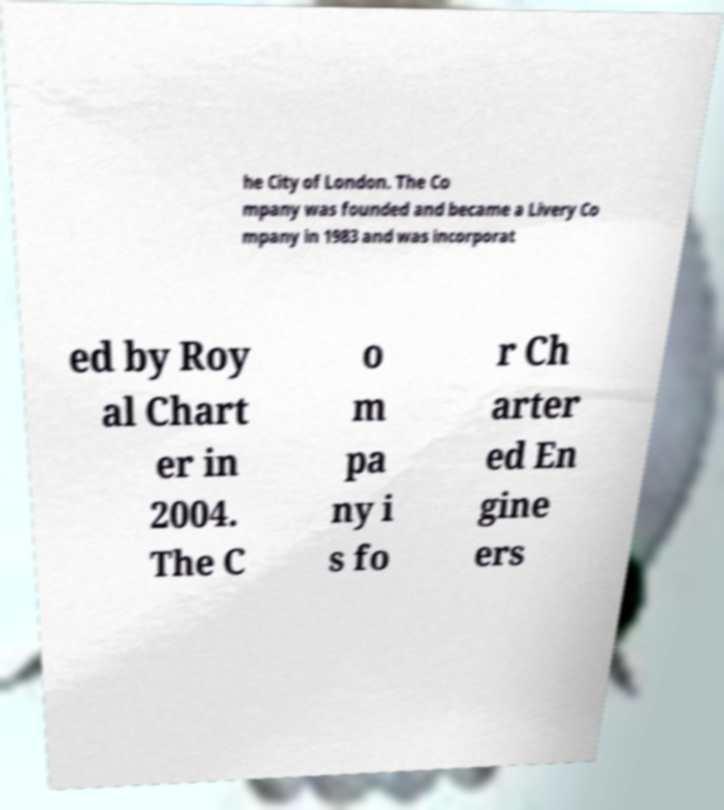I need the written content from this picture converted into text. Can you do that? he City of London. The Co mpany was founded and became a Livery Co mpany in 1983 and was incorporat ed by Roy al Chart er in 2004. The C o m pa ny i s fo r Ch arter ed En gine ers 